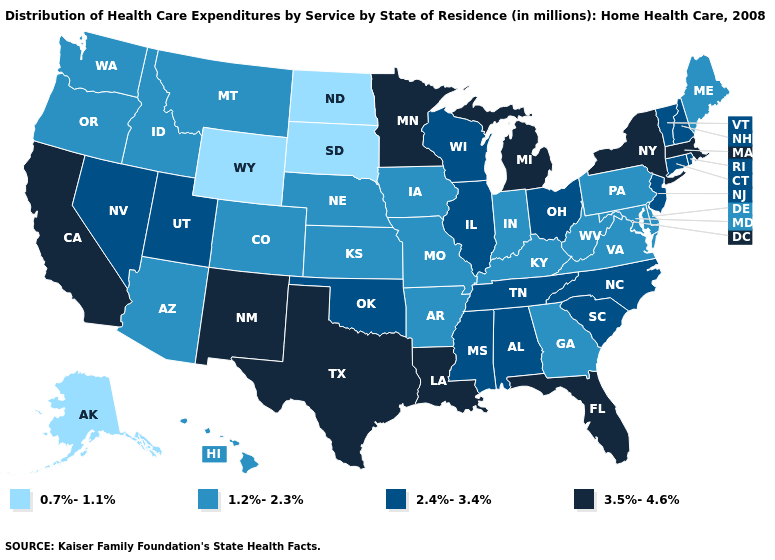Name the states that have a value in the range 3.5%-4.6%?
Give a very brief answer. California, Florida, Louisiana, Massachusetts, Michigan, Minnesota, New Mexico, New York, Texas. Does North Dakota have the lowest value in the USA?
Keep it brief. Yes. What is the value of Nevada?
Quick response, please. 2.4%-3.4%. Name the states that have a value in the range 1.2%-2.3%?
Short answer required. Arizona, Arkansas, Colorado, Delaware, Georgia, Hawaii, Idaho, Indiana, Iowa, Kansas, Kentucky, Maine, Maryland, Missouri, Montana, Nebraska, Oregon, Pennsylvania, Virginia, Washington, West Virginia. What is the value of Texas?
Give a very brief answer. 3.5%-4.6%. What is the value of Nevada?
Write a very short answer. 2.4%-3.4%. Name the states that have a value in the range 2.4%-3.4%?
Answer briefly. Alabama, Connecticut, Illinois, Mississippi, Nevada, New Hampshire, New Jersey, North Carolina, Ohio, Oklahoma, Rhode Island, South Carolina, Tennessee, Utah, Vermont, Wisconsin. Is the legend a continuous bar?
Keep it brief. No. Does Montana have the highest value in the USA?
Answer briefly. No. Does Georgia have a higher value than Washington?
Keep it brief. No. Among the states that border New Hampshire , which have the lowest value?
Quick response, please. Maine. Which states hav the highest value in the West?
Give a very brief answer. California, New Mexico. What is the lowest value in the Northeast?
Concise answer only. 1.2%-2.3%. What is the highest value in the USA?
Be succinct. 3.5%-4.6%. Does New York have the highest value in the Northeast?
Keep it brief. Yes. 